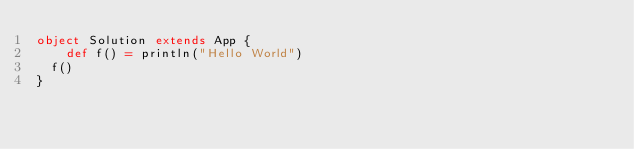<code> <loc_0><loc_0><loc_500><loc_500><_Scala_>object Solution extends App {
	def f() = println("Hello World")
  f()
}</code> 